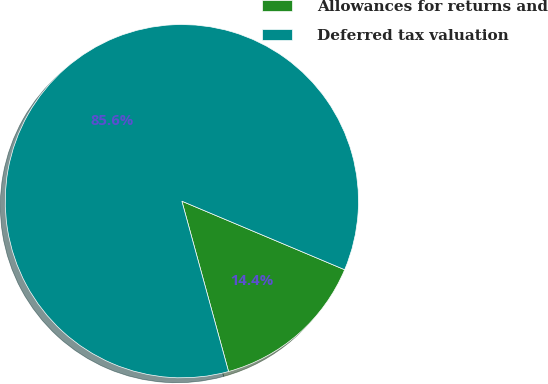<chart> <loc_0><loc_0><loc_500><loc_500><pie_chart><fcel>Allowances for returns and<fcel>Deferred tax valuation<nl><fcel>14.4%<fcel>85.6%<nl></chart> 